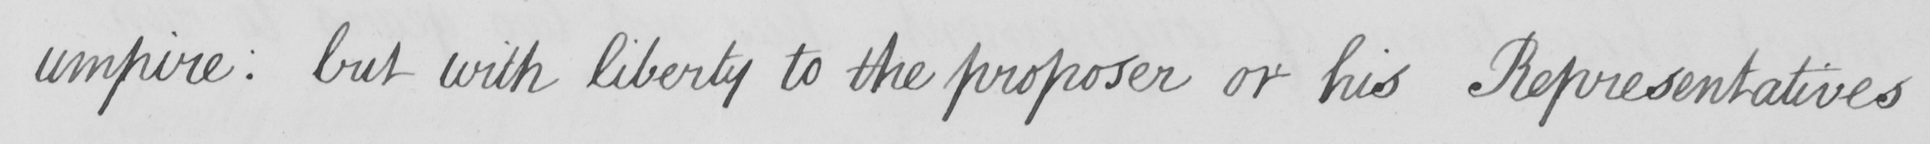Please provide the text content of this handwritten line. umpire :  but with liberty to the proposer or his Representatives 